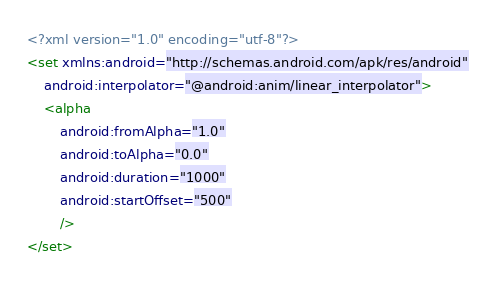Convert code to text. <code><loc_0><loc_0><loc_500><loc_500><_XML_><?xml version="1.0" encoding="utf-8"?>
<set xmlns:android="http://schemas.android.com/apk/res/android"
    android:interpolator="@android:anim/linear_interpolator">
    <alpha
        android:fromAlpha="1.0"
        android:toAlpha="0.0"
        android:duration="1000"
        android:startOffset="500"
        />
</set></code> 